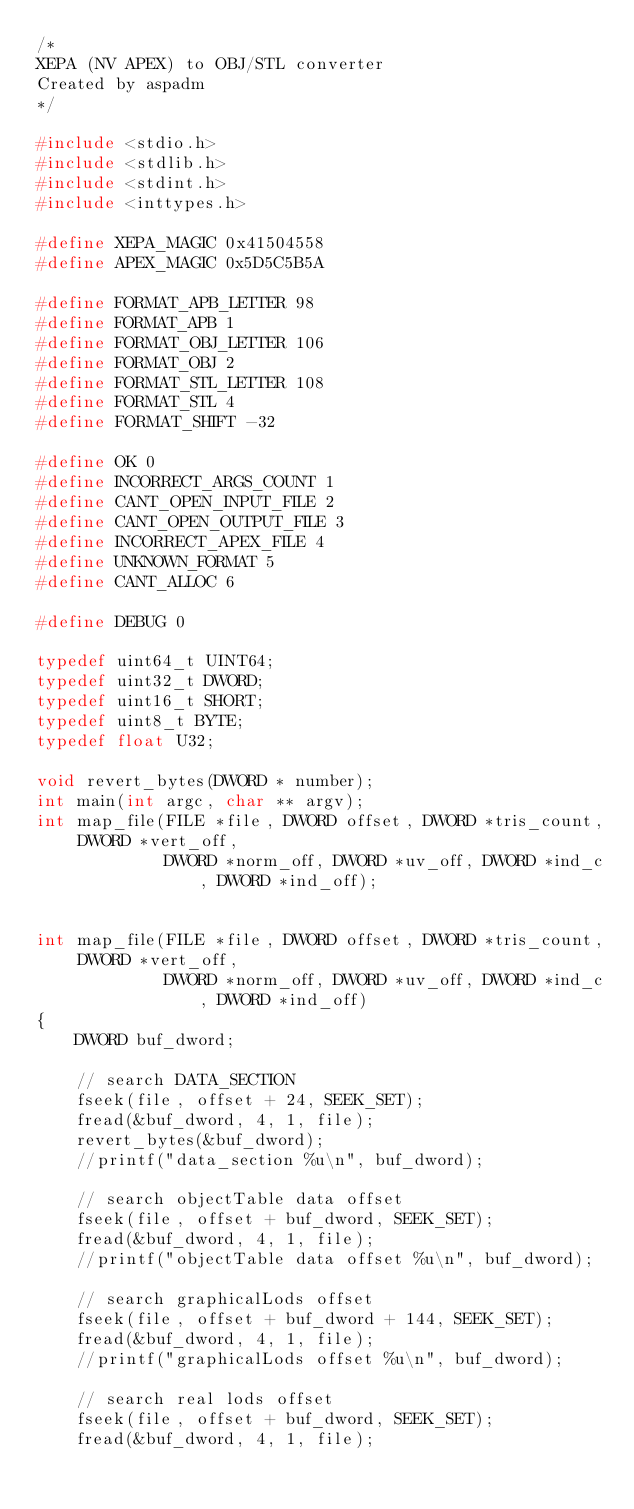Convert code to text. <code><loc_0><loc_0><loc_500><loc_500><_C_>/*
XEPA (NV APEX) to OBJ/STL converter
Created by aspadm
*/

#include <stdio.h>
#include <stdlib.h>
#include <stdint.h>
#include <inttypes.h>

#define XEPA_MAGIC 0x41504558
#define APEX_MAGIC 0x5D5C5B5A

#define FORMAT_APB_LETTER 98
#define FORMAT_APB 1
#define FORMAT_OBJ_LETTER 106
#define FORMAT_OBJ 2
#define FORMAT_STL_LETTER 108
#define FORMAT_STL 4
#define FORMAT_SHIFT -32

#define OK 0
#define INCORRECT_ARGS_COUNT 1
#define CANT_OPEN_INPUT_FILE 2
#define CANT_OPEN_OUTPUT_FILE 3
#define INCORRECT_APEX_FILE 4
#define UNKNOWN_FORMAT 5
#define CANT_ALLOC 6

#define DEBUG 0

typedef uint64_t UINT64;
typedef uint32_t DWORD;
typedef uint16_t SHORT;
typedef uint8_t BYTE;
typedef float U32;

void revert_bytes(DWORD * number);
int main(int argc, char ** argv);
int map_file(FILE *file, DWORD offset, DWORD *tris_count, DWORD *vert_off,
			 DWORD *norm_off, DWORD *uv_off, DWORD *ind_c, DWORD *ind_off);


int map_file(FILE *file, DWORD offset, DWORD *tris_count, DWORD *vert_off,
			 DWORD *norm_off, DWORD *uv_off, DWORD *ind_c, DWORD *ind_off)
{
	DWORD buf_dword;
	
	// search DATA_SECTION
	fseek(file, offset + 24, SEEK_SET);
	fread(&buf_dword, 4, 1, file);
	revert_bytes(&buf_dword);
	//printf("data_section %u\n", buf_dword);
	
	// search objectTable data offset
	fseek(file, offset + buf_dword, SEEK_SET);
	fread(&buf_dword, 4, 1, file);
	//printf("objectTable data offset %u\n", buf_dword);
	
	// search graphicalLods offset
	fseek(file, offset + buf_dword + 144, SEEK_SET);
	fread(&buf_dword, 4, 1, file);
	//printf("graphicalLods offset %u\n", buf_dword);
	
	// search real lods offset
	fseek(file, offset + buf_dword, SEEK_SET);
	fread(&buf_dword, 4, 1, file);</code> 